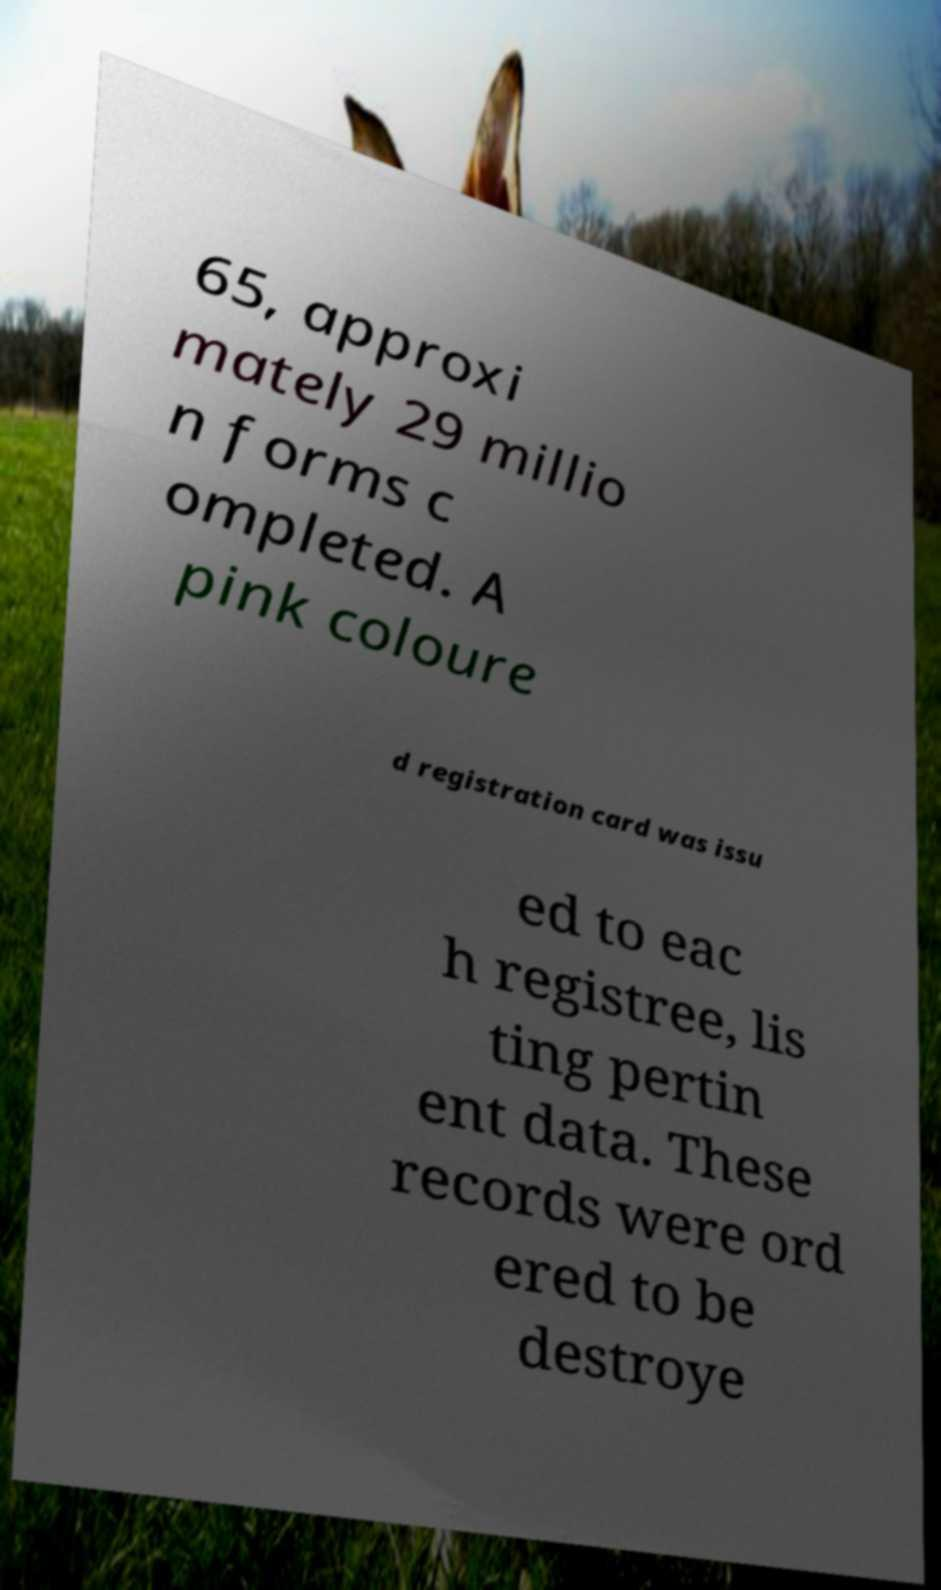What messages or text are displayed in this image? I need them in a readable, typed format. 65, approxi mately 29 millio n forms c ompleted. A pink coloure d registration card was issu ed to eac h registree, lis ting pertin ent data. These records were ord ered to be destroye 